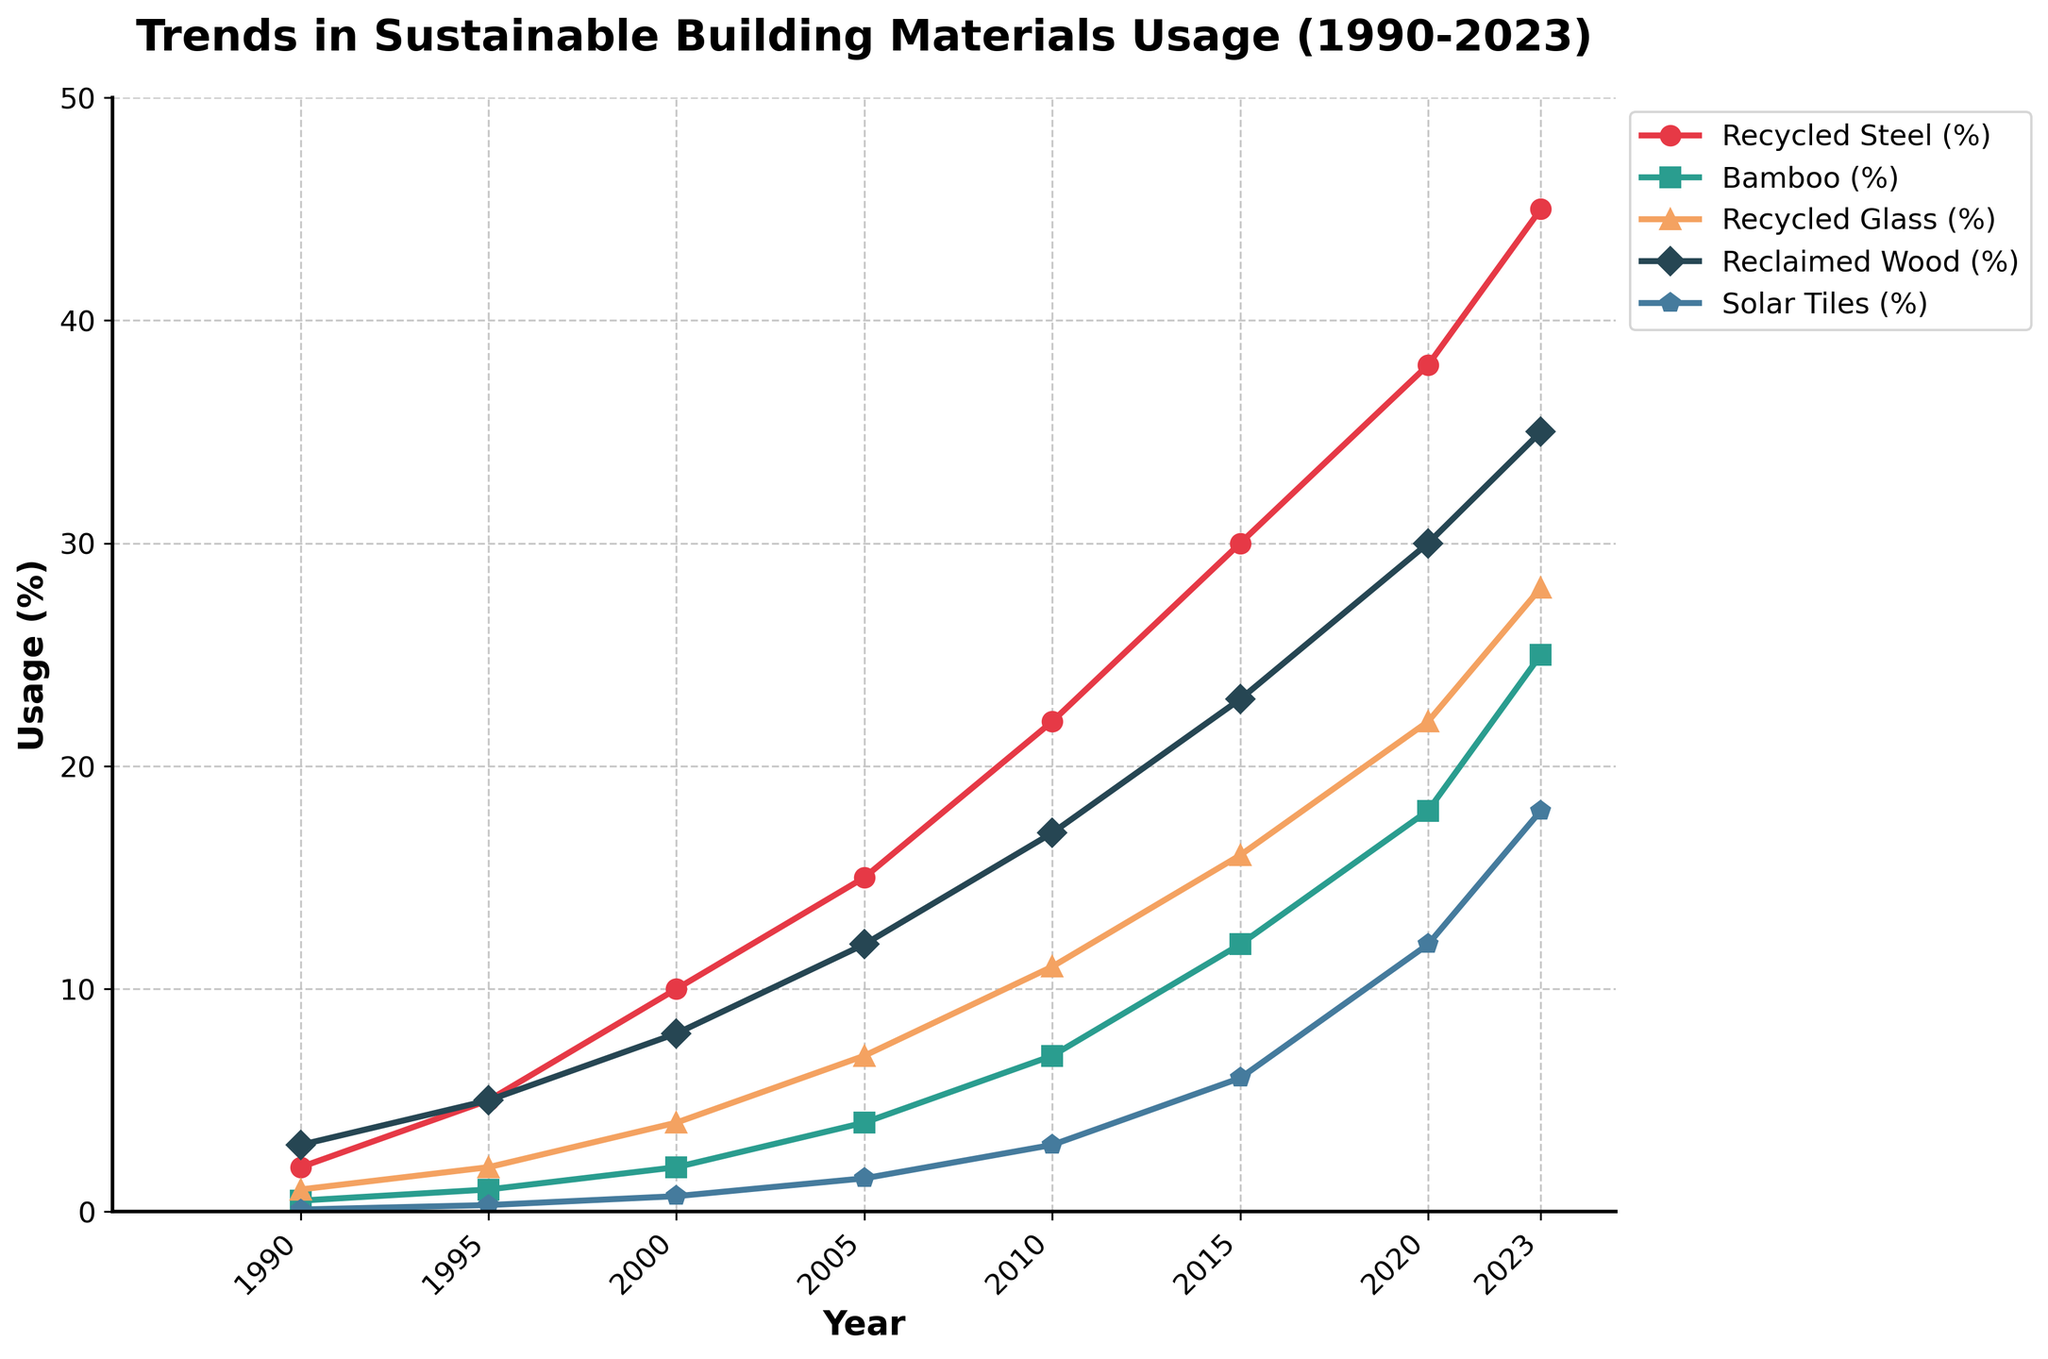What's the usage difference of Recycled Steel between 1990 and 2023? To find the difference, subtract the 1990 value from the 2023 value (45 - 2)
Answer: 43 Between 2000 and 2020, which material showed the largest increase in usage percentage? Calculate the increase for each material from 2000 to 2020. Recycled Steel increased by 28%, Bamboo by 16%, Recycled Glass by 18%, Reclaimed Wood by 22%, Solar Tiles by 11.3%.
Answer: Recycled Steel Which material had the lowest usage in 2015 and what was its percentage? Look at the data points for 2015 and find the lowest value (Bamboo at 12%)
Answer: Bamboo, 12% In which year did Recycled Steel usage first exceed 20%? Check the Recycled Steel trend line and find the first year when it crossed the 20% mark, which is 2010
Answer: 2010 How does the usage of Solar Tiles in 2023 compare to 1990 in terms of percentage increase? Calculate the percentage increase: ((18 - 0.1) / 0.1) * 100 = 17,900%
Answer: 17,900% What is the average usage percentage of Bamboo over the years given? Sum all percentages (0.5 + 1 + 2 + 4 + 7 + 12 + 18 + 25) and divide by the number of years, 8: (0.5 + 1 + 2 + 4 + 7 + 12 + 18 + 25) / 8 = 8.75%
Answer: 8.75% Compare the trend of Reclaimed Wood to Recycled Glass between 1990 and 2023. Which one increased more rapidly overall? Calculate the rate of increase for each. Reclaimed Wood: 35 - 3 = 32%. Recycled Glass: 28 - 1 = 27%.
Answer: Reclaimed Wood Which year did Reclaimed Wood surpass 20% usage? Find the first year in the Reclaimed Wood trend line that crosses 20%, which is 2015
Answer: 2015 Between 1995 and 2005, which material showed the smallest change in usage percentage? Calculate the changes for each material in that period: Recycled Steel (+10%), Bamboo (+3%), Recycled Glass (+5%), Reclaimed Wood (+7%), Solar Tiles (+1.2%).
Answer: Solar Tiles In what year did Bamboo usage start showing significant growth above 5%? By observing the Bamboo trend line, it surpasses 5% between 2005 and 2010, so the significant growth starts in 2010
Answer: 2010 